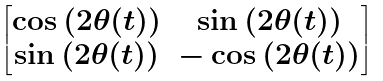Convert formula to latex. <formula><loc_0><loc_0><loc_500><loc_500>\begin{bmatrix} \cos \left ( 2 \theta ( t ) \right ) & \sin \left ( 2 \theta ( t ) \right ) \\ \sin \left ( 2 \theta ( t ) \right ) & - \cos \left ( 2 \theta ( t ) \right ) \end{bmatrix}</formula> 